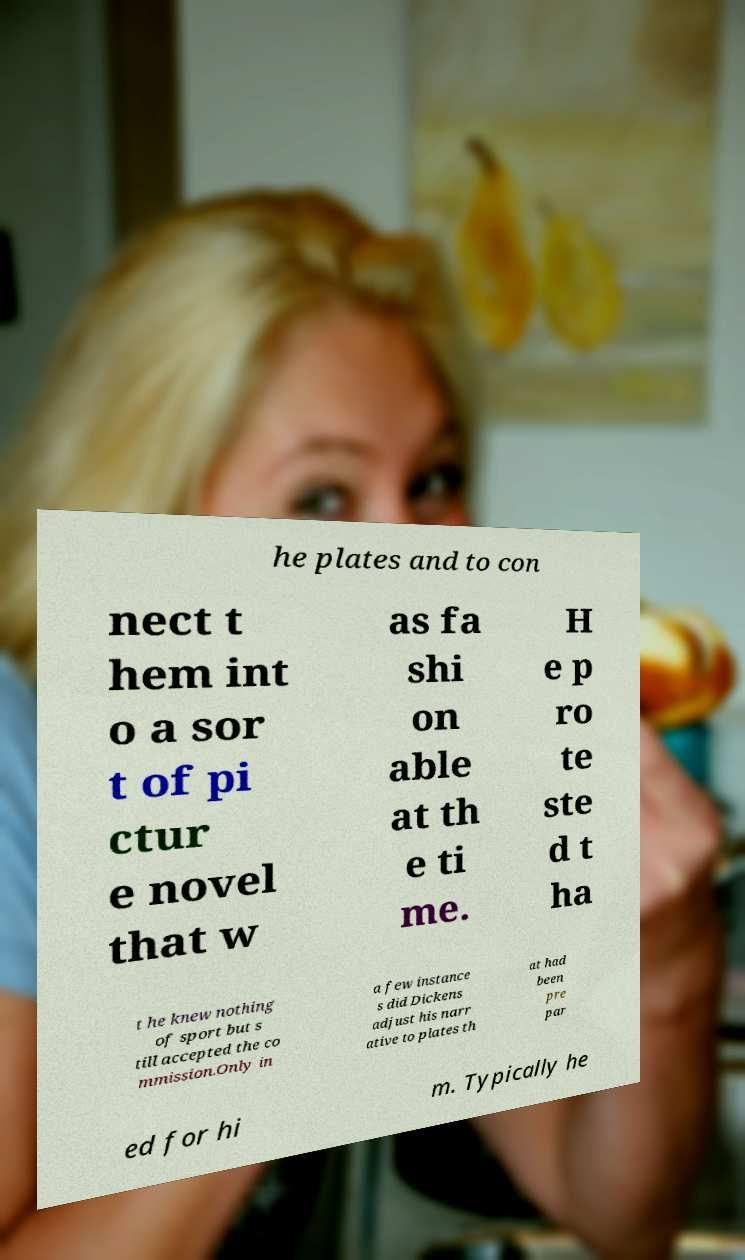What messages or text are displayed in this image? I need them in a readable, typed format. he plates and to con nect t hem int o a sor t of pi ctur e novel that w as fa shi on able at th e ti me. H e p ro te ste d t ha t he knew nothing of sport but s till accepted the co mmission.Only in a few instance s did Dickens adjust his narr ative to plates th at had been pre par ed for hi m. Typically he 